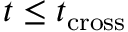<formula> <loc_0><loc_0><loc_500><loc_500>t \leq t _ { c r o s s }</formula> 